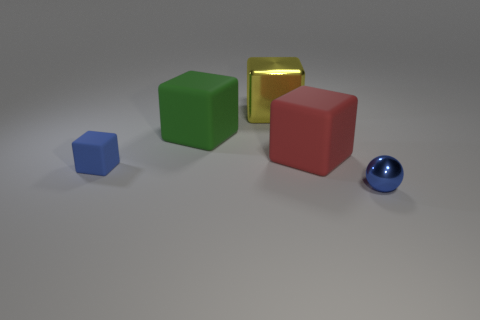What material is the object that is in front of the large red rubber object and on the right side of the blue rubber cube?
Provide a succinct answer. Metal. There is a shiny ball; does it have the same color as the tiny thing that is on the left side of the blue metallic ball?
Ensure brevity in your answer.  Yes. There is a green cube that is the same size as the yellow metallic object; what material is it?
Keep it short and to the point. Rubber. Is there a tiny blue object made of the same material as the green cube?
Your response must be concise. Yes. How many blue things are there?
Ensure brevity in your answer.  2. Does the big green cube have the same material as the blue object that is to the right of the small blue rubber cube?
Make the answer very short. No. What material is the small thing that is the same color as the sphere?
Offer a terse response. Rubber. How many tiny spheres are the same color as the metallic cube?
Offer a very short reply. 0. The red object has what size?
Provide a succinct answer. Large. There is a large green thing; does it have the same shape as the tiny blue object that is on the right side of the big metal block?
Provide a short and direct response. No. 